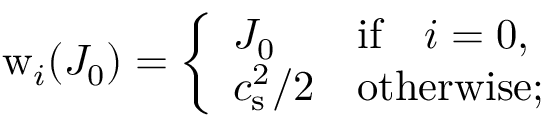Convert formula to latex. <formula><loc_0><loc_0><loc_500><loc_500>w _ { i } ( J _ { 0 } ) = \left \{ \begin{array} { l l } { J _ { 0 } } & { i f \quad i = 0 , } \\ { c _ { s } ^ { 2 } / 2 } & { o t h e r w i s e ; } \end{array}</formula> 